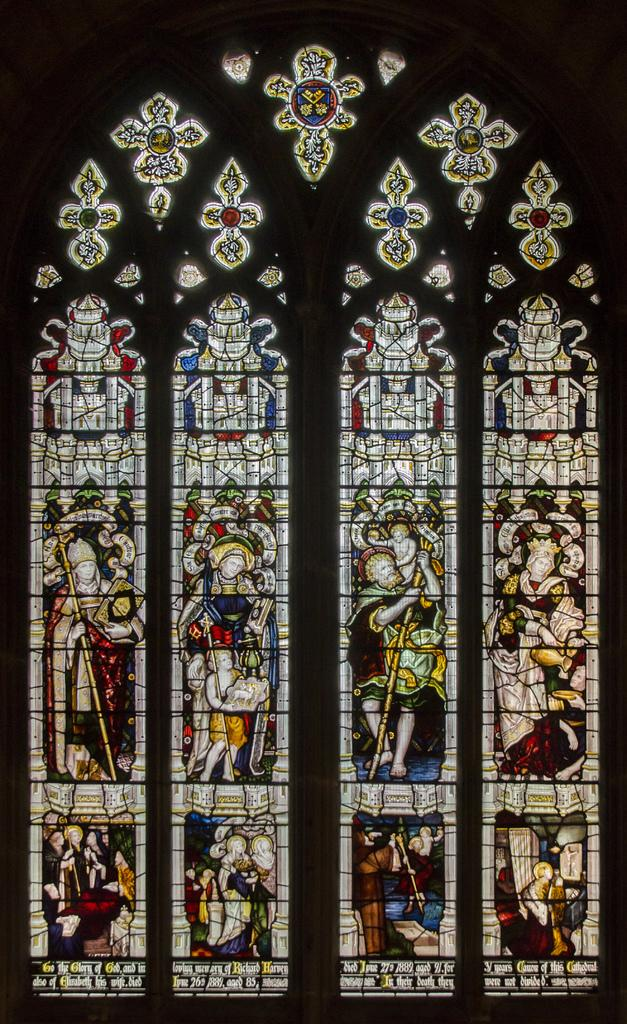What can be seen in the image related to a source of light? There is a window in the image. What feature of the window is mentioned in the facts? The window has colorful glass paintings. How many toes are visible on the brain in the image? There is no brain or toes present in the image. 